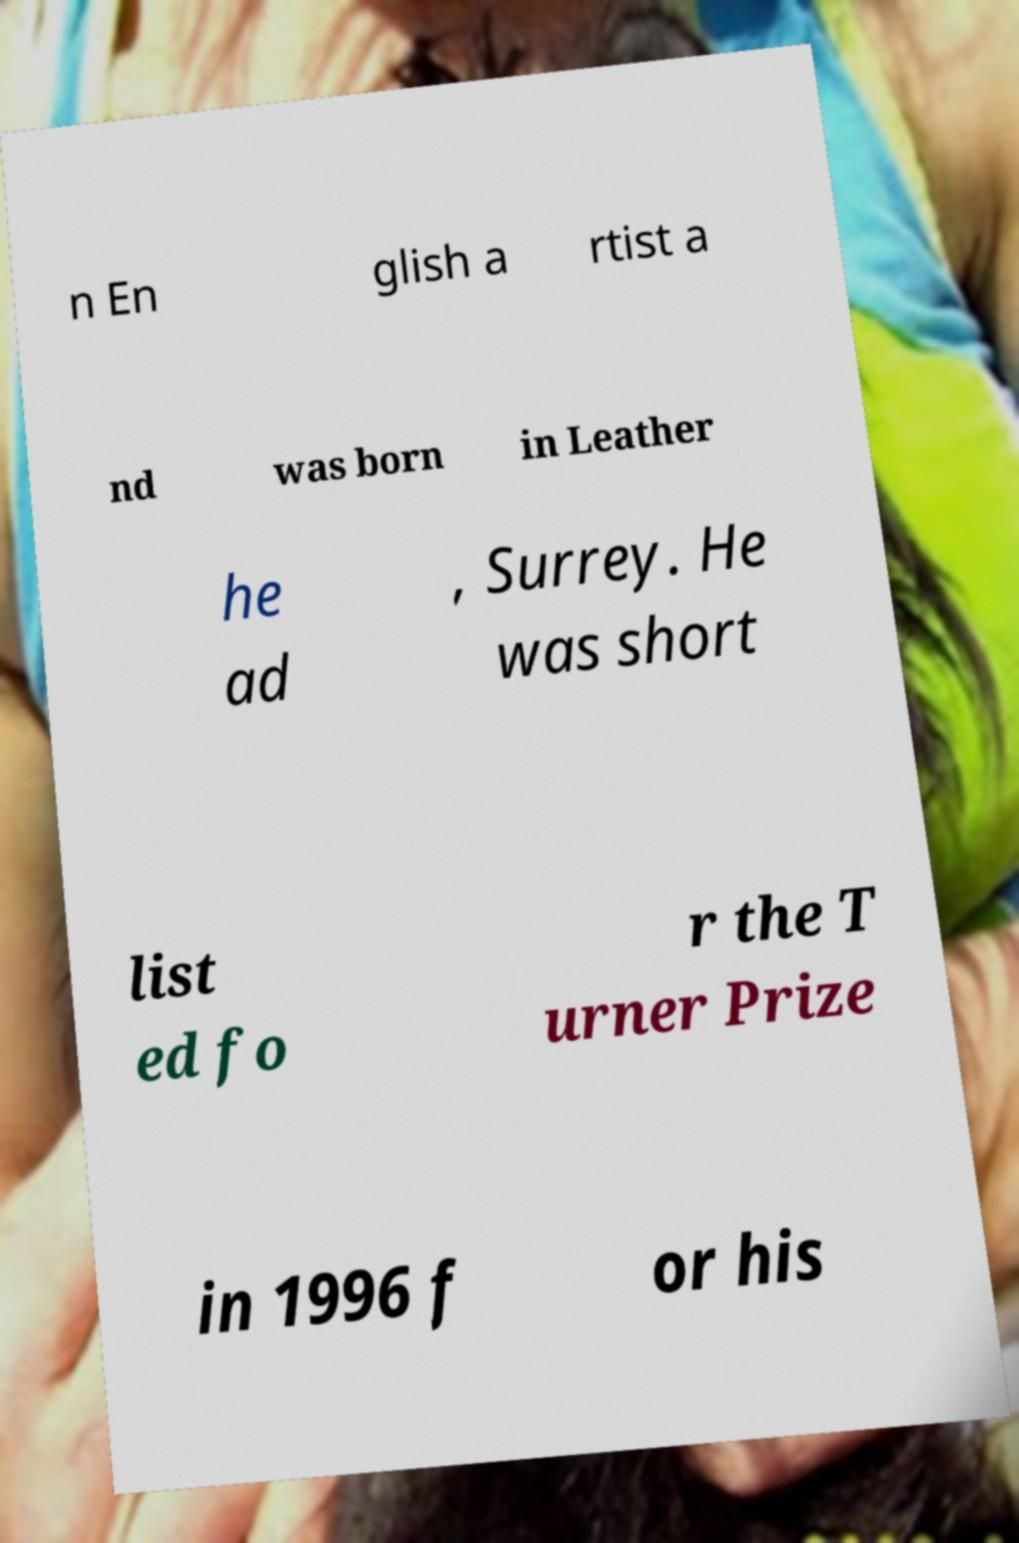There's text embedded in this image that I need extracted. Can you transcribe it verbatim? n En glish a rtist a nd was born in Leather he ad , Surrey. He was short list ed fo r the T urner Prize in 1996 f or his 